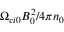Convert formula to latex. <formula><loc_0><loc_0><loc_500><loc_500>\Omega _ { c i 0 } B _ { 0 } ^ { 2 } / 4 \pi n _ { 0 }</formula> 